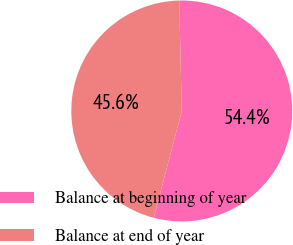<chart> <loc_0><loc_0><loc_500><loc_500><pie_chart><fcel>Balance at beginning of year<fcel>Balance at end of year<nl><fcel>54.44%<fcel>45.56%<nl></chart> 